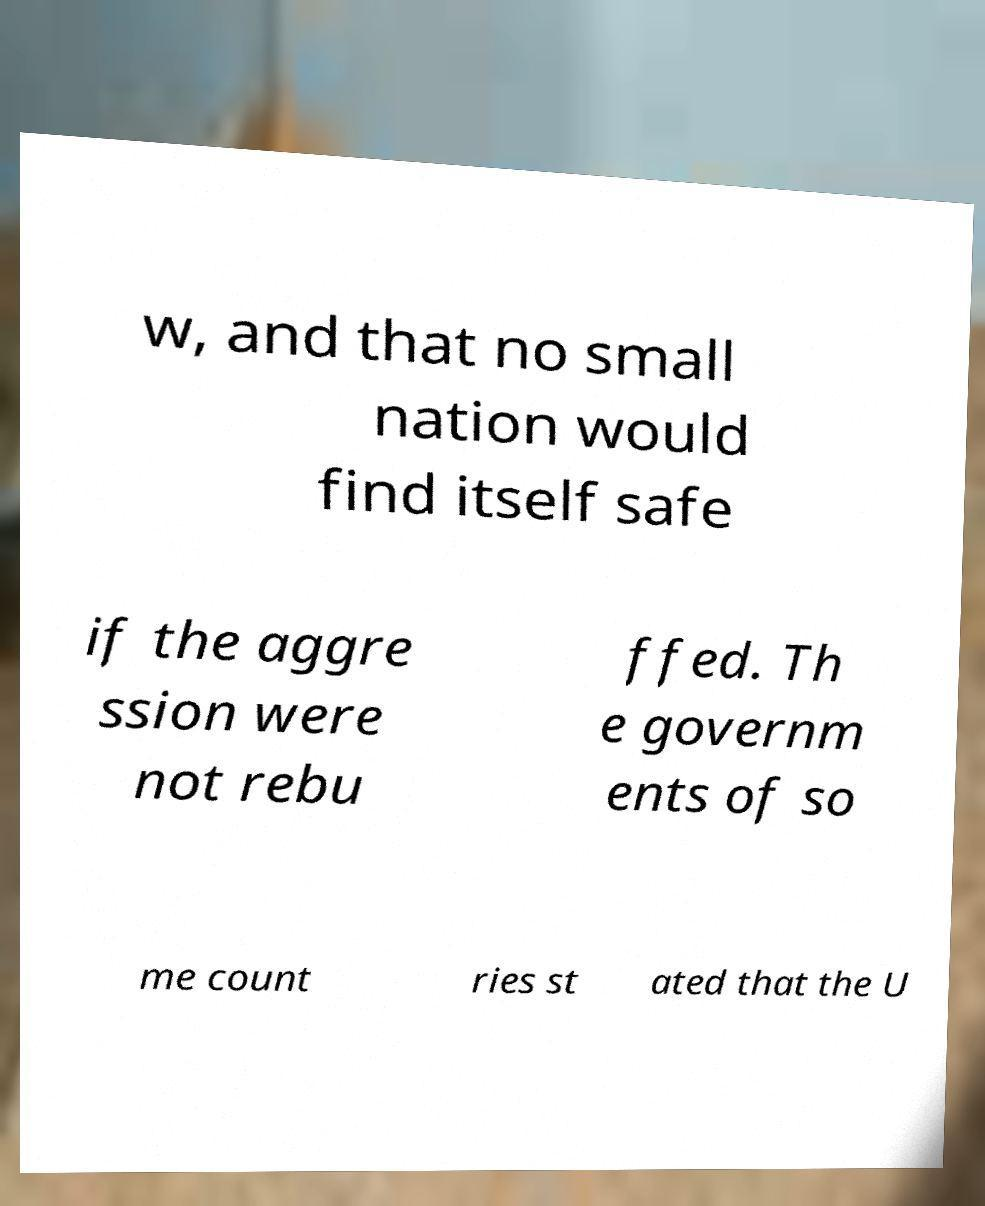What messages or text are displayed in this image? I need them in a readable, typed format. w, and that no small nation would find itself safe if the aggre ssion were not rebu ffed. Th e governm ents of so me count ries st ated that the U 